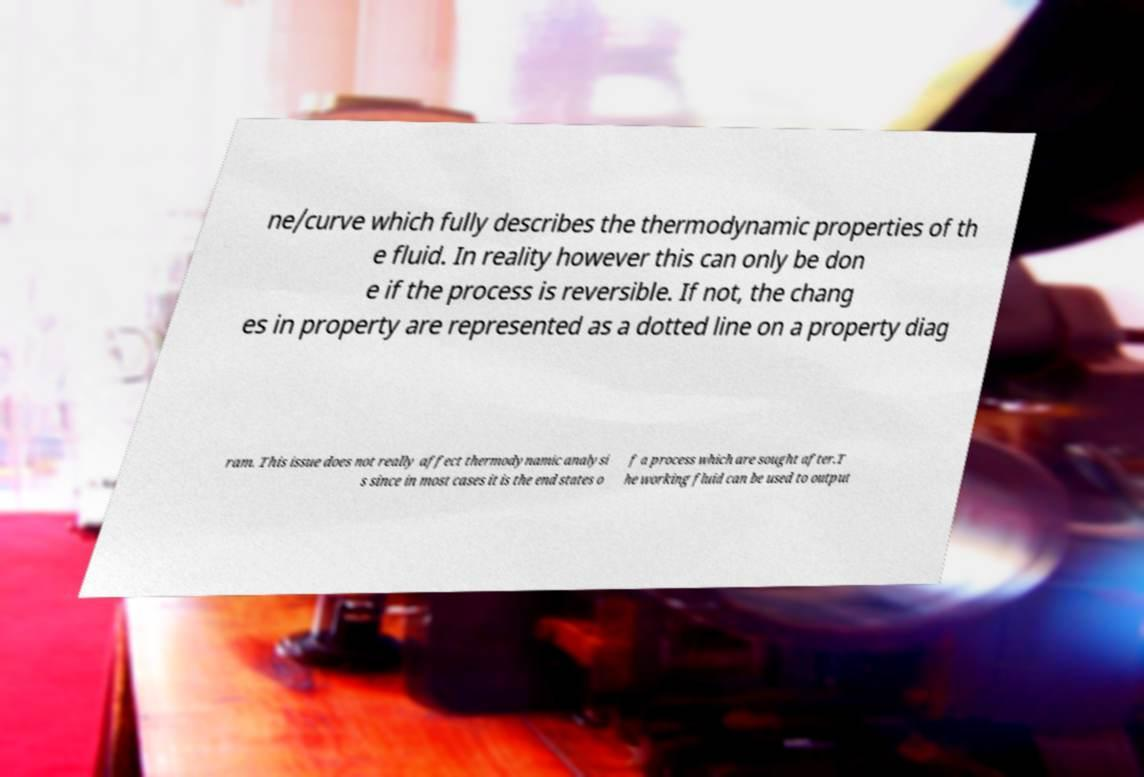There's text embedded in this image that I need extracted. Can you transcribe it verbatim? ne/curve which fully describes the thermodynamic properties of th e fluid. In reality however this can only be don e if the process is reversible. If not, the chang es in property are represented as a dotted line on a property diag ram. This issue does not really affect thermodynamic analysi s since in most cases it is the end states o f a process which are sought after.T he working fluid can be used to output 